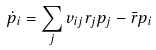Convert formula to latex. <formula><loc_0><loc_0><loc_500><loc_500>\dot { p } _ { i } = \sum _ { j } v _ { i j } r _ { j } p _ { j } - \bar { r } p _ { i } \,</formula> 